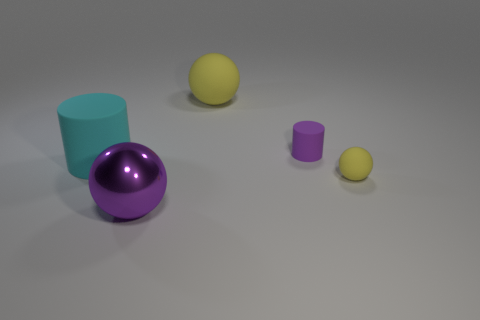What is the material of the purple object behind the large sphere in front of the matte thing behind the purple cylinder?
Offer a very short reply. Rubber. Are there any gray matte blocks of the same size as the purple rubber thing?
Ensure brevity in your answer.  No. What color is the cylinder in front of the small matte object to the left of the tiny yellow matte thing?
Your answer should be compact. Cyan. How many small yellow blocks are there?
Offer a very short reply. 0. Is the color of the metallic thing the same as the large matte sphere?
Make the answer very short. No. Is the number of yellow balls behind the cyan rubber object less than the number of small things in front of the large yellow matte thing?
Keep it short and to the point. Yes. The big shiny sphere has what color?
Give a very brief answer. Purple. What number of objects are the same color as the tiny rubber sphere?
Your answer should be compact. 1. Are there any tiny purple cylinders behind the tiny purple cylinder?
Provide a succinct answer. No. Is the number of balls that are behind the small purple cylinder the same as the number of yellow objects in front of the large metal sphere?
Ensure brevity in your answer.  No. 